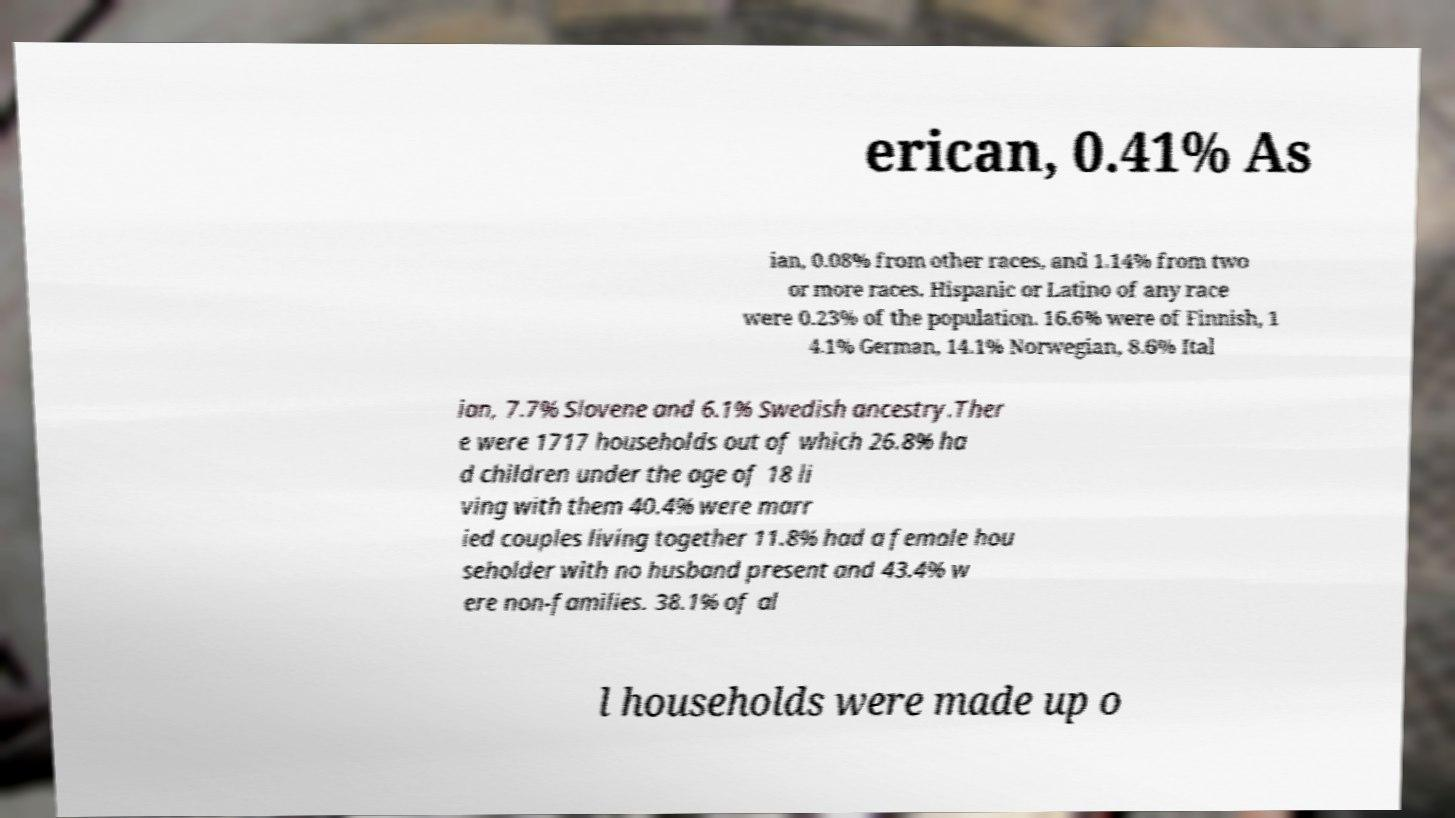I need the written content from this picture converted into text. Can you do that? erican, 0.41% As ian, 0.08% from other races, and 1.14% from two or more races. Hispanic or Latino of any race were 0.23% of the population. 16.6% were of Finnish, 1 4.1% German, 14.1% Norwegian, 8.6% Ital ian, 7.7% Slovene and 6.1% Swedish ancestry.Ther e were 1717 households out of which 26.8% ha d children under the age of 18 li ving with them 40.4% were marr ied couples living together 11.8% had a female hou seholder with no husband present and 43.4% w ere non-families. 38.1% of al l households were made up o 